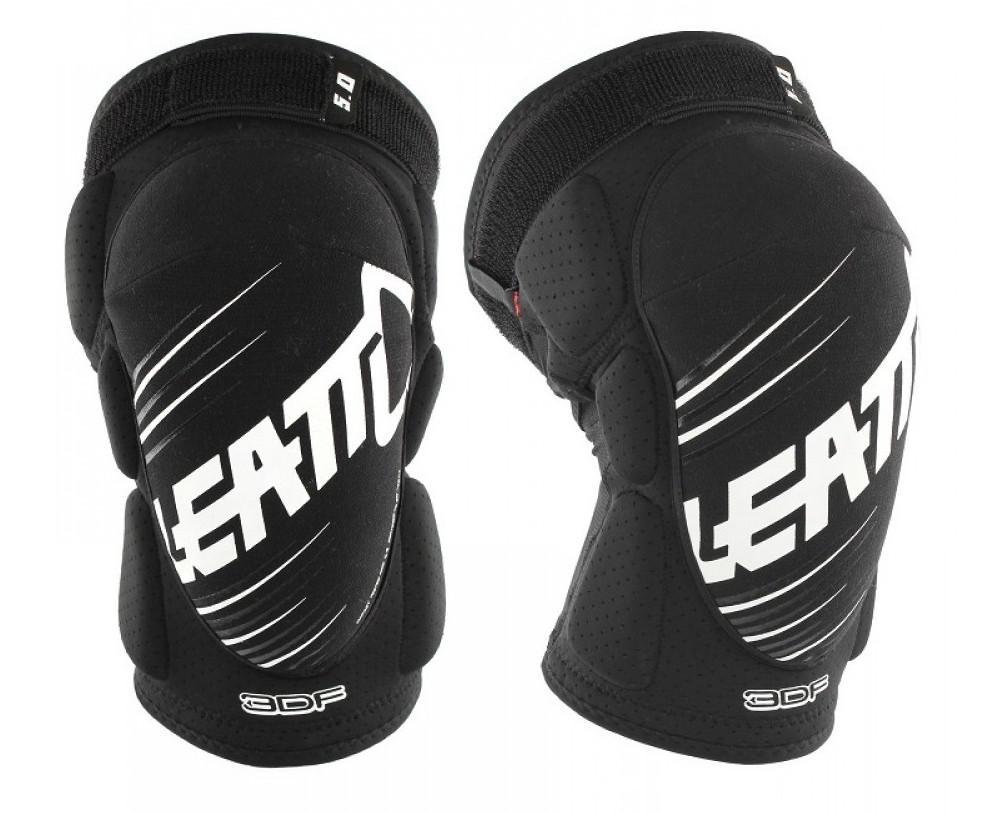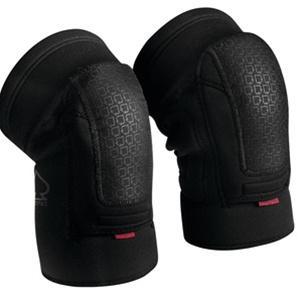The first image is the image on the left, the second image is the image on the right. Given the left and right images, does the statement "The left image shows at least one pair of knee caps that are being worn on a person's legs" hold true? Answer yes or no. No. The first image is the image on the left, the second image is the image on the right. Evaluate the accuracy of this statement regarding the images: "An image includes a pair of human legs wearing black knee-pads.". Is it true? Answer yes or no. No. 